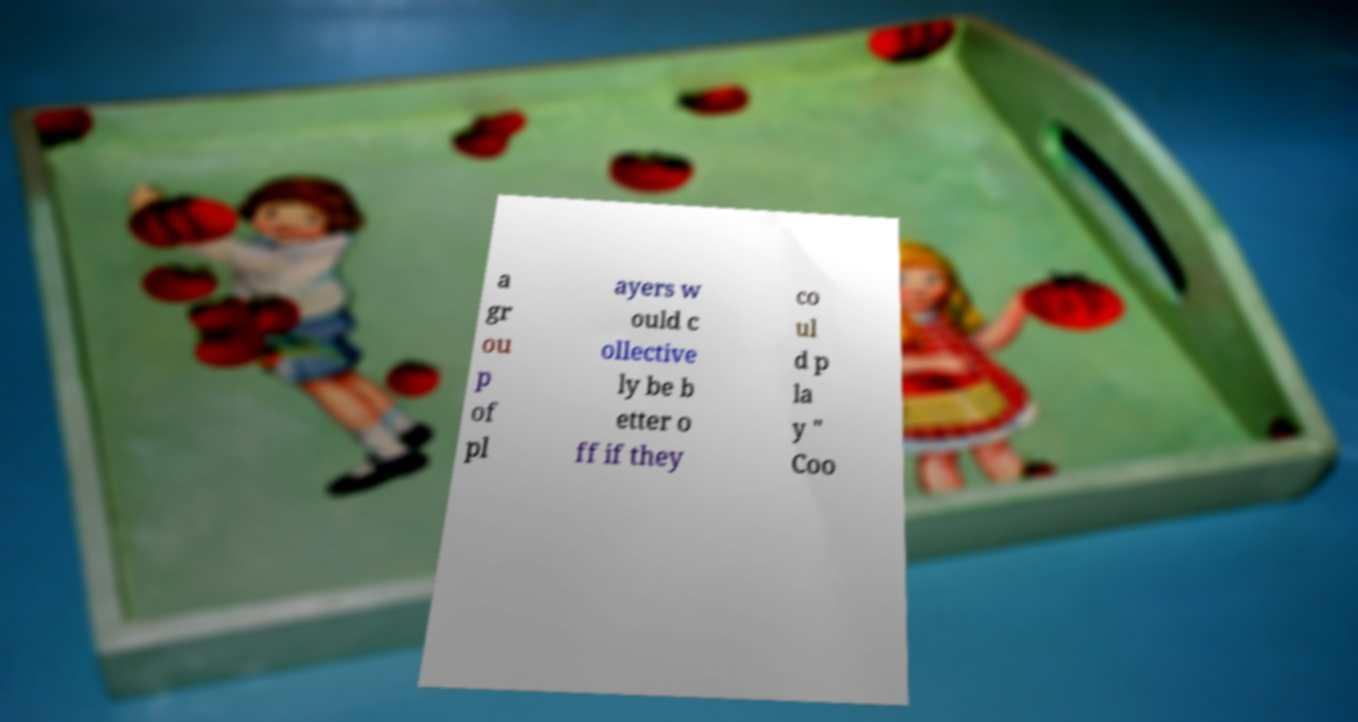Please identify and transcribe the text found in this image. a gr ou p of pl ayers w ould c ollective ly be b etter o ff if they co ul d p la y " Coo 